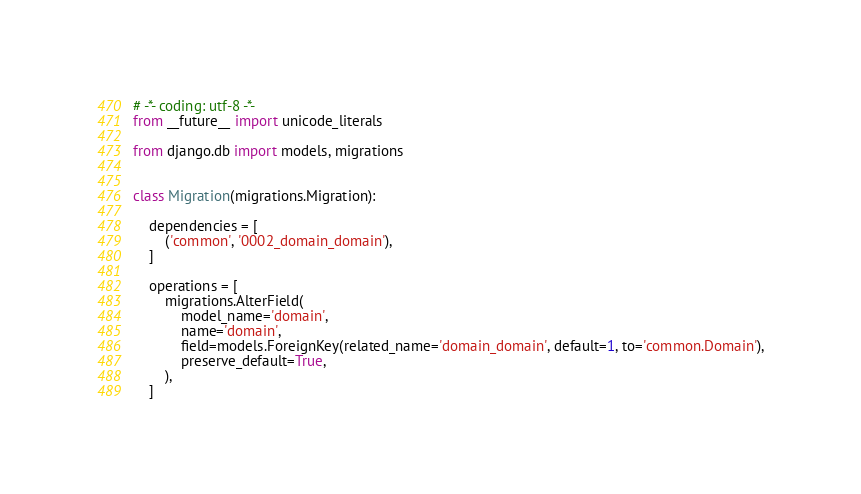Convert code to text. <code><loc_0><loc_0><loc_500><loc_500><_Python_># -*- coding: utf-8 -*-
from __future__ import unicode_literals

from django.db import models, migrations


class Migration(migrations.Migration):

    dependencies = [
        ('common', '0002_domain_domain'),
    ]

    operations = [
        migrations.AlterField(
            model_name='domain',
            name='domain',
            field=models.ForeignKey(related_name='domain_domain', default=1, to='common.Domain'),
            preserve_default=True,
        ),
    ]
</code> 